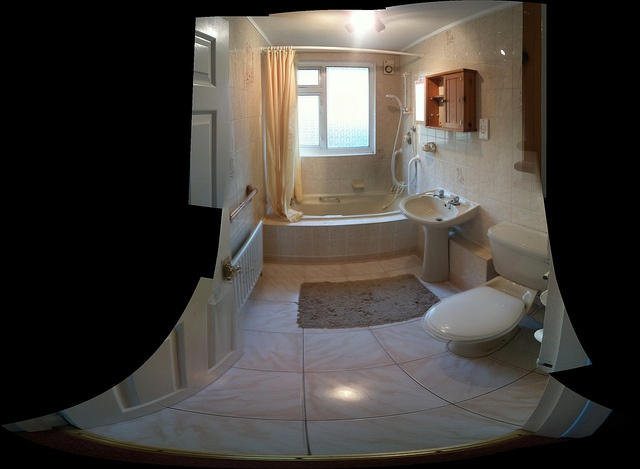Describe the objects in this image and their specific colors. I can see toilet in black and gray tones and sink in black, darkgray, and gray tones in this image. 